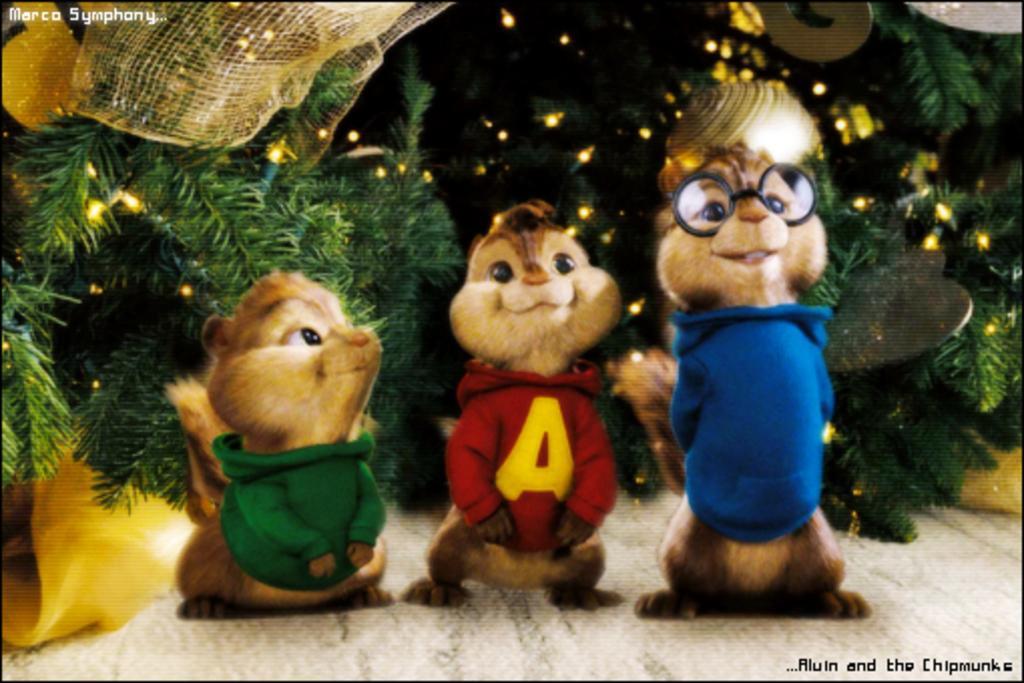In one or two sentences, can you explain what this image depicts? This is an animated picture. In the background we can see the trees decorated with lights and few objects. We can the squirrels wearing colorful dresses. On the right we can see a squirrel wearing spectacle. In the top left and in the bottom right corner of the picture we can see there is something written. 